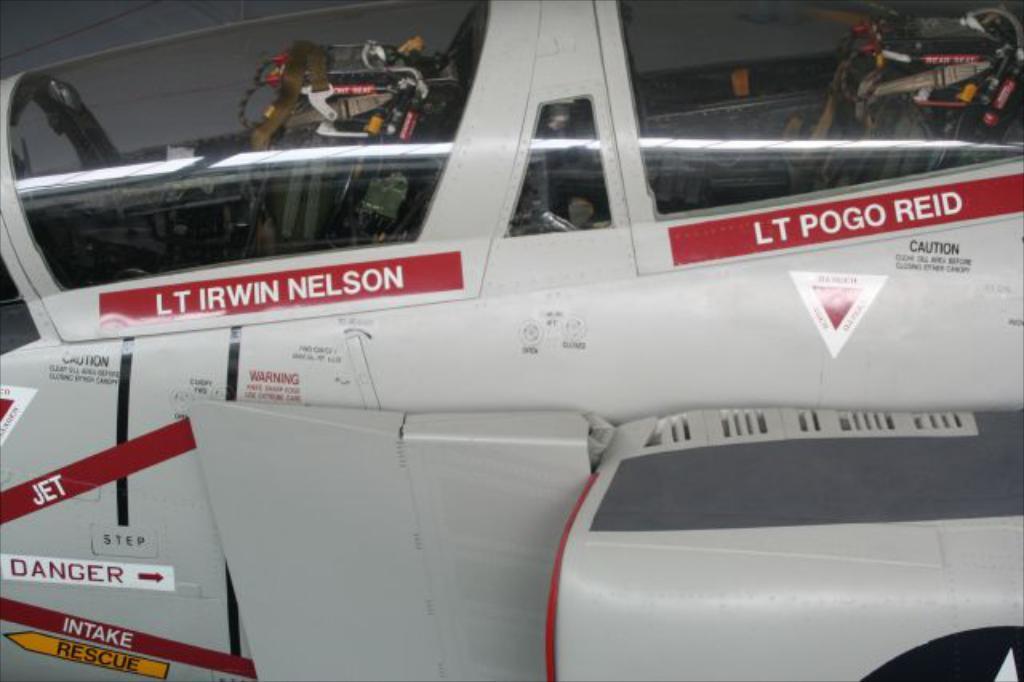What is the name of the pilot?
Keep it short and to the point. Irwin nelson. Is danger written on the vehicle?
Ensure brevity in your answer.  Yes. 